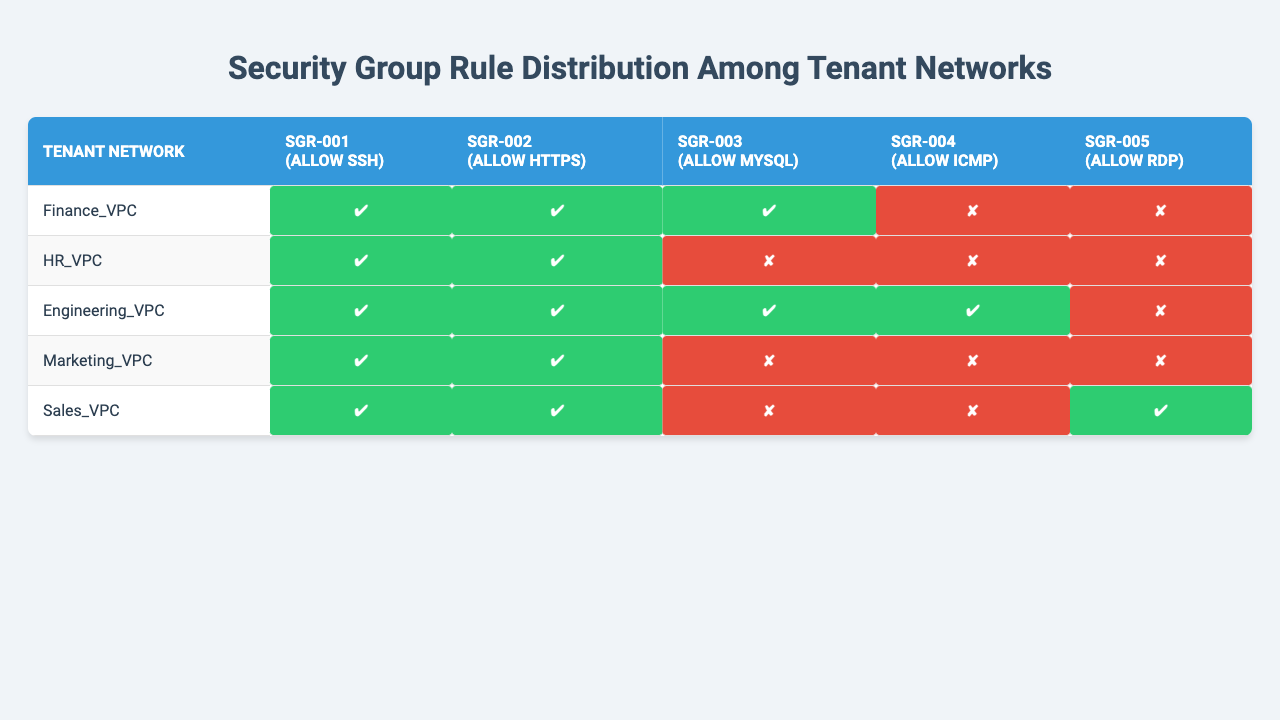What security group rules are present in Finance_VPC? The table shows that Finance_VPC has three rules: SGR-001 (Allow SSH), SGR-002 (Allow HTTPS), and SGR-003 (Allow MySQL).
Answer: SGR-001, SGR-002, SGR-003 How many security group rules does Engineering_VPC have? By checking the table, Engineering_VPC includes four rules: SGR-001, SGR-002, SGR-003, and SGR-004.
Answer: 4 Is ICMP allowed in HR_VPC? The table indicates that HR_VPC does not have SGR-004 (Allow ICMP), which means ICMP is not allowed.
Answer: No Which tenant network has the most security group rules? By comparing the counts of rules across tenant networks in the table, Engineering_VPC has the most with four rules.
Answer: Engineering_VPC Are there any tenant networks that allow RDP? The table shows that only Sales_VPC includes SGR-005 (Allow RDP), indicating that it is the only tenant network that allows RDP.
Answer: Yes, Sales_VPC What is the total number of security group rules across all tenant networks? There are five unique security group rules listed in the table. Therefore, the total is 5.
Answer: 5 Which two tenant networks have the same number of security group rules? HR_VPC and Marketing_VPC each have two rules, as reflected in the table.
Answer: HR_VPC and Marketing_VPC What is the percentage of tenant networks that allow both SSH and HTTPS? There are 5 tenant networks; 4 of them allow both SSH (SGR-001) and HTTPS (SGR-002). Thus, the percentage is (4/5) * 100 = 80%.
Answer: 80% Is it true that Sales_VPC allows both SSH and RDP? The table shows Sales_VPC has SGR-001 (Allow SSH) and SGR-005 (Allow RDP), confirming this statement as true.
Answer: Yes What unique security group rules are allocated to Sales_VPC compared to HR_VPC? Sales_VPC has one unique rule, SGR-005 (Allow RDP), not represented in HR_VPC.
Answer: SGR-005 (Allow RDP) 